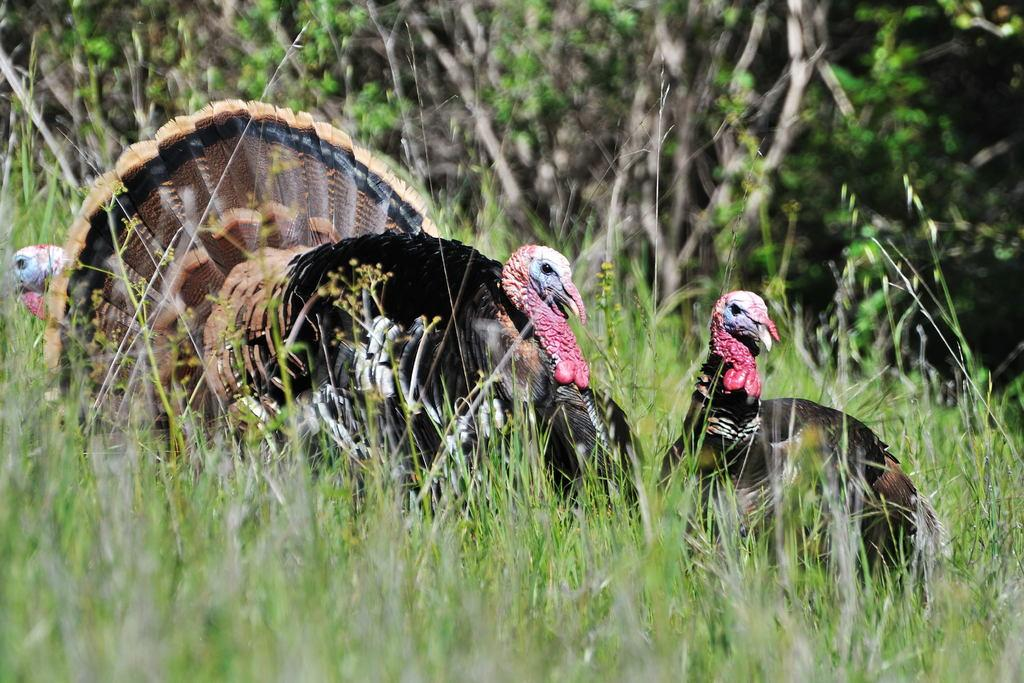What type of vegetation is at the bottom of the image? There is grass at the bottom of the image. What animals can be seen in the image? There are birds visible in the image. What object is on the ground in the image? There is an object on the ground, but its specific nature is not mentioned in the facts. What can be seen in the background of the image? There are plants in the background of the image. How does the sheep in the image express hope? There is no sheep present in the image, so it cannot express hope. 